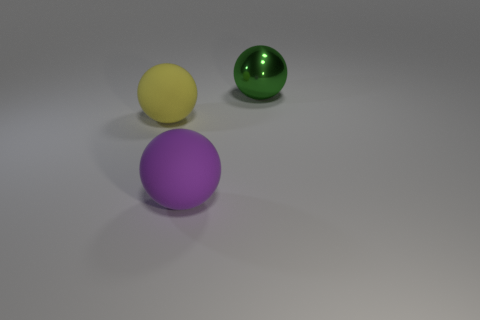What can you infer about the lighting in this scene? The scene appears to be softly lit with a diffuse light source, given the gentle shadows cast by the spheres and the lack of harsh reflections, except on the green, shiny sphere which has a stronger highlight. Does the lighting suggest anything about the setting? The even and soft lighting, along with the neutral background, suggests a controlled environment, possibly a studio setup designed to highlight the objects without any distractions. 